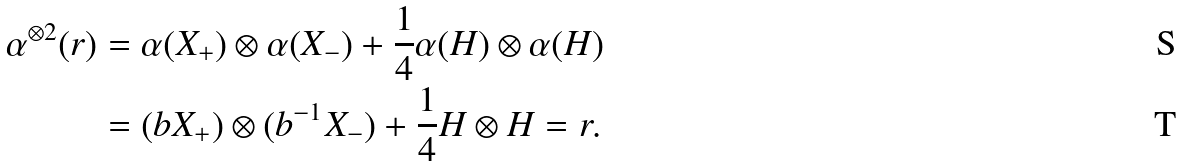<formula> <loc_0><loc_0><loc_500><loc_500>\alpha ^ { \otimes 2 } ( r ) & = \alpha ( X _ { + } ) \otimes \alpha ( X _ { - } ) + \frac { 1 } { 4 } \alpha ( H ) \otimes \alpha ( H ) \\ & = ( b X _ { + } ) \otimes ( b ^ { - 1 } X _ { - } ) + \frac { 1 } { 4 } H \otimes H = r .</formula> 